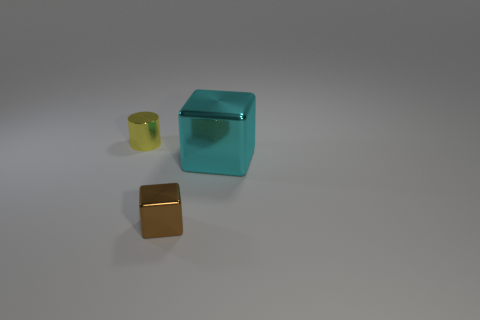There is another thing that is the same shape as the brown metallic thing; what material is it?
Give a very brief answer. Metal. Is there anything else that has the same material as the small block?
Your answer should be compact. Yes. Is the large cube the same color as the small shiny cube?
Offer a very short reply. No. What is the shape of the small thing that is in front of the small metal thing behind the large metallic thing?
Provide a succinct answer. Cube. There is a small thing that is the same material as the brown block; what shape is it?
Give a very brief answer. Cylinder. What number of other things are there of the same shape as the yellow object?
Provide a succinct answer. 0. There is a metallic thing that is on the right side of the brown metal object; is it the same size as the yellow shiny object?
Your answer should be compact. No. Are there more brown shiny cubes that are on the right side of the tiny brown shiny block than small metallic cylinders?
Keep it short and to the point. No. There is a tiny metal object that is to the right of the cylinder; what number of metallic cylinders are left of it?
Provide a succinct answer. 1. Are there fewer big cyan shiny objects in front of the yellow cylinder than big shiny things?
Give a very brief answer. No. 